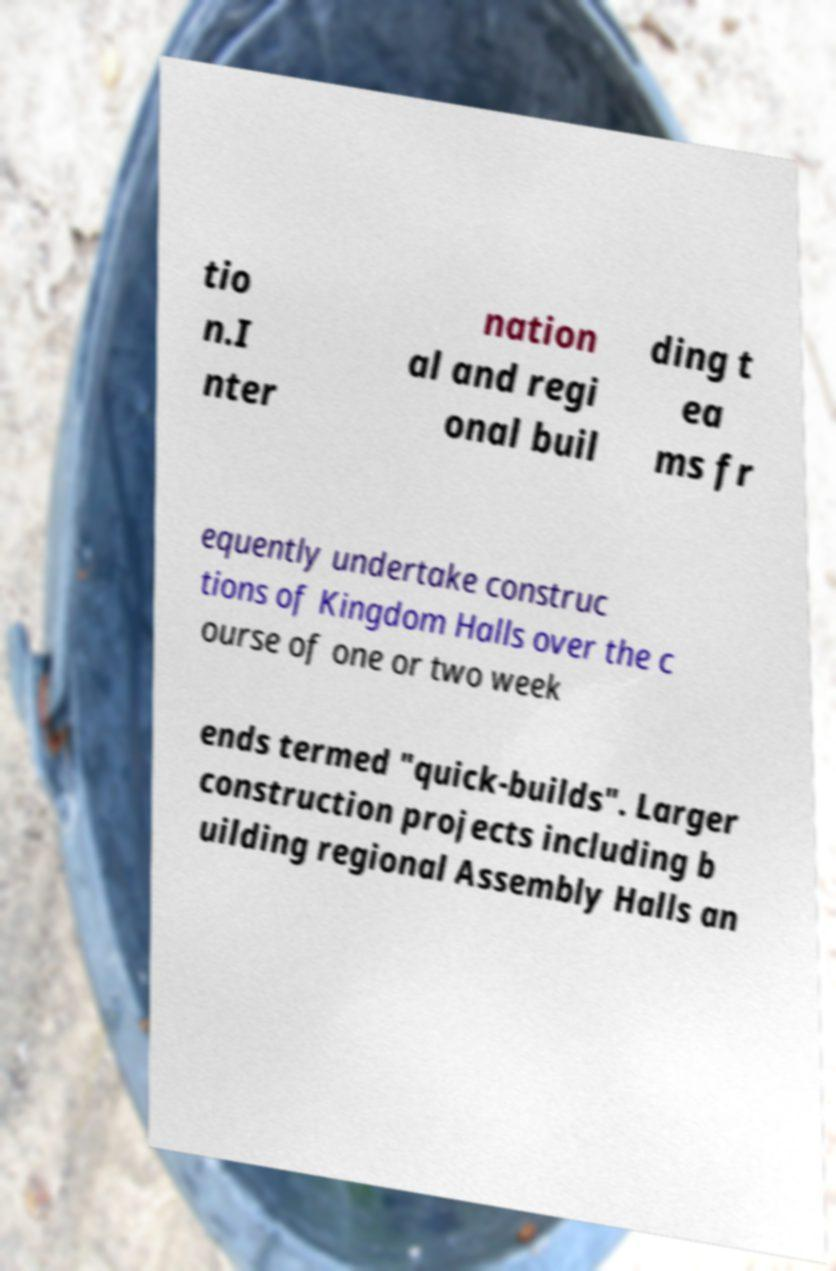Please identify and transcribe the text found in this image. tio n.I nter nation al and regi onal buil ding t ea ms fr equently undertake construc tions of Kingdom Halls over the c ourse of one or two week ends termed "quick-builds". Larger construction projects including b uilding regional Assembly Halls an 